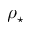<formula> <loc_0><loc_0><loc_500><loc_500>\rho _ { ^ { * } }</formula> 